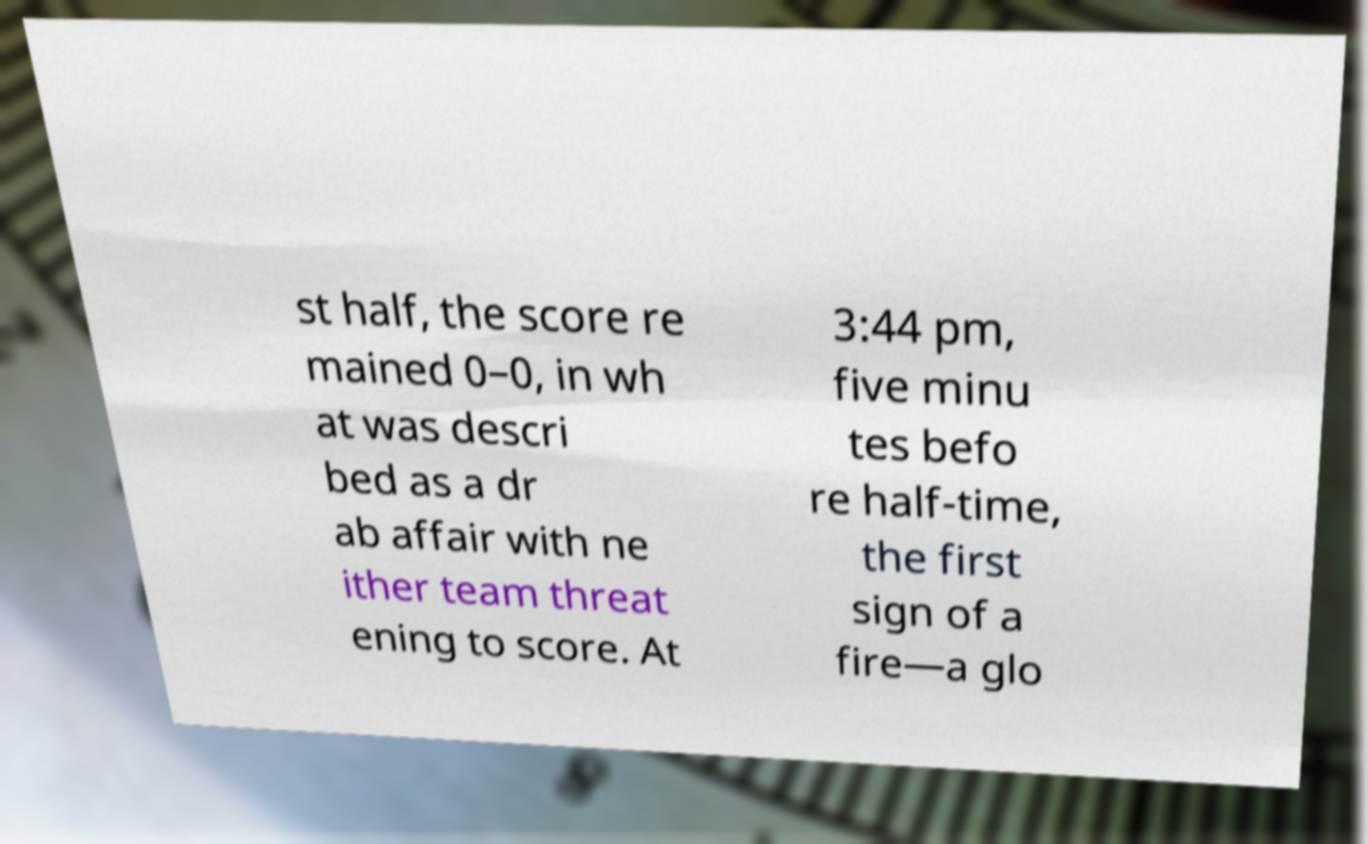For documentation purposes, I need the text within this image transcribed. Could you provide that? st half, the score re mained 0–0, in wh at was descri bed as a dr ab affair with ne ither team threat ening to score. At 3:44 pm, five minu tes befo re half-time, the first sign of a fire—a glo 